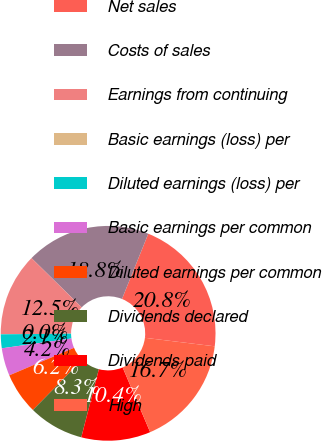Convert chart. <chart><loc_0><loc_0><loc_500><loc_500><pie_chart><fcel>Net sales<fcel>Costs of sales<fcel>Earnings from continuing<fcel>Basic earnings (loss) per<fcel>Diluted earnings (loss) per<fcel>Basic earnings per common<fcel>Diluted earnings per common<fcel>Dividends declared<fcel>Dividends paid<fcel>High<nl><fcel>20.83%<fcel>18.75%<fcel>12.5%<fcel>0.0%<fcel>2.08%<fcel>4.17%<fcel>6.25%<fcel>8.33%<fcel>10.42%<fcel>16.67%<nl></chart> 